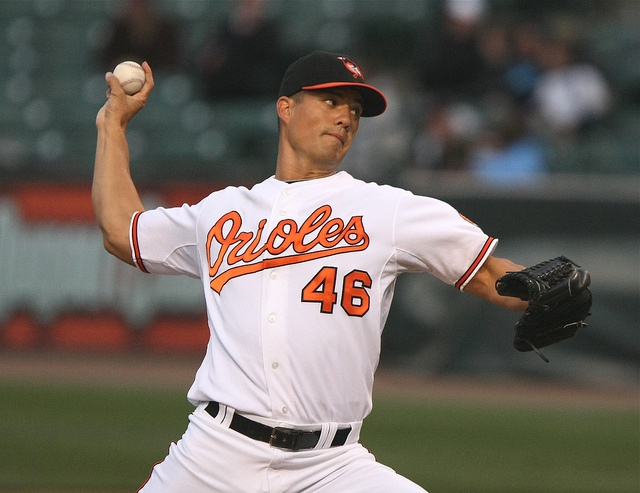Describe the objects in this image and their specific colors. I can see people in purple, lavender, black, gray, and darkgray tones, baseball glove in purple, black, and gray tones, and sports ball in purple, tan, and beige tones in this image. 